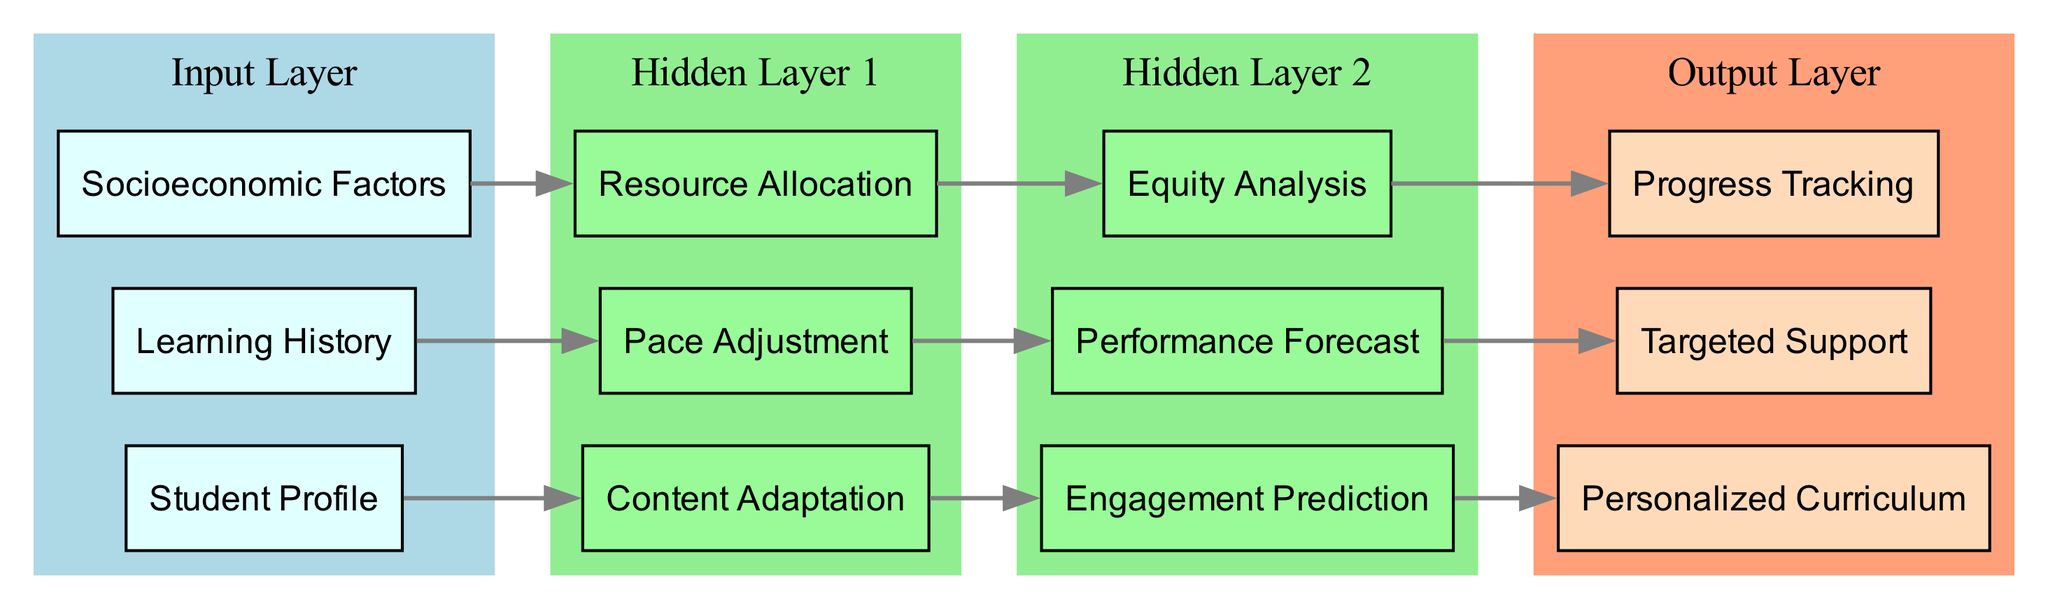What nodes are in the input layer? The input layer consists of three nodes: "Student Profile", "Learning History", and "Socioeconomic Factors". Each node represents a different type of input relevant to personalizing learning experiences.
Answer: Student Profile, Learning History, Socioeconomic Factors How many nodes are in the output layer? The output layer contains three nodes: "Personalized Curriculum", "Targeted Support", and "Progress Tracking". This can be counted directly from the diagram's output layer section.
Answer: 3 Which hidden layer node is connected to "Learning History"? "Pace Adjustment" is connected to "Learning History". This connection indicates that data from the learning history is used to adjust the pace of the online learning experience.
Answer: Pace Adjustment What is the connection between "Resource Allocation" and "Equity Analysis"? "Resource Allocation" directly feeds into "Equity Analysis". This means that the resources allocated based on the input data are analyzed for equity considerations in the learning environment.
Answer: Equity Analysis How many connections lead to the output layer? There are three connections leading to the output layer, one for each output node: "Personalized Curriculum", "Targeted Support", and "Progress Tracking". Each node receives inputs from specific hidden layer nodes.
Answer: 3 Which output node is linked to "Engagement Prediction"? "Personalized Curriculum" is linked to "Engagement Prediction". This indicates that engagement predictions inform the development of a personalized curriculum for each student.
Answer: Personalized Curriculum Which hidden layer node contributes to "Targeted Support"? "Performance Forecast" contributes to "Targeted Support". This connection suggests that performance predictions are directly used to identify areas where students may need targeted assistance.
Answer: Performance Forecast What is the purpose of the "Content Adaptation" node? The "Content Adaptation" node's purpose is to modify learning materials based on inputs from the "Student Profile", contributing to a more personalized learning experience. It then influences engagement predictions.
Answer: Modify learning materials What is the role of "Progress Tracking" in this architecture? "Progress Tracking" plays a crucial role by monitoring students' advancements and outcomes, helping to ensure that learning experiences remain tailored and effective.
Answer: Monitor advancements 